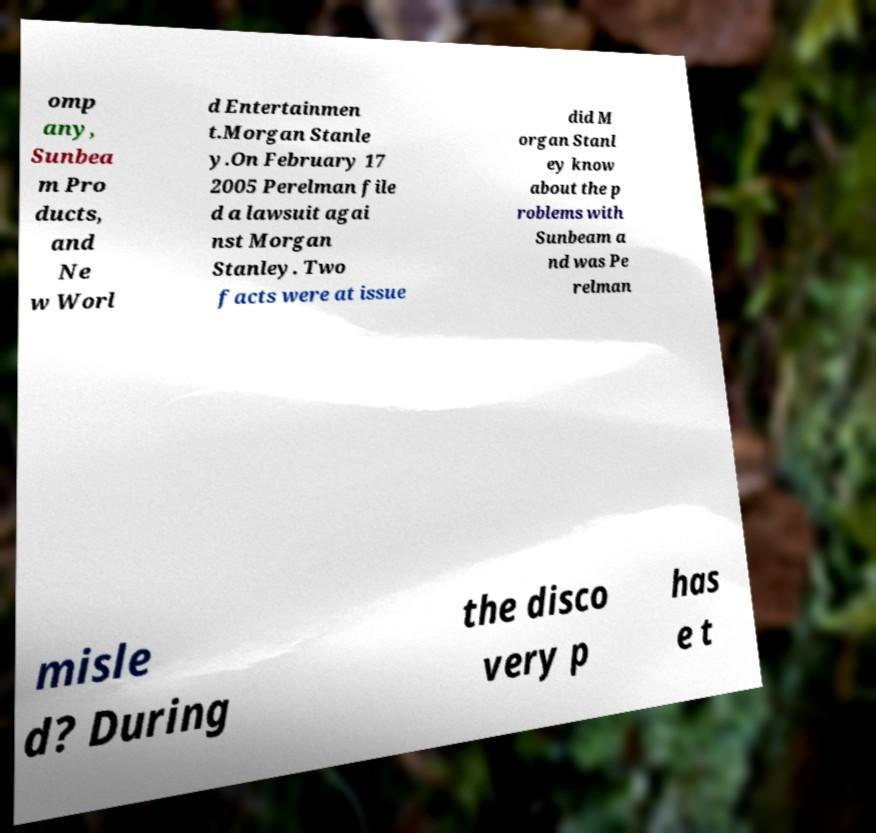I need the written content from this picture converted into text. Can you do that? omp any, Sunbea m Pro ducts, and Ne w Worl d Entertainmen t.Morgan Stanle y.On February 17 2005 Perelman file d a lawsuit agai nst Morgan Stanley. Two facts were at issue did M organ Stanl ey know about the p roblems with Sunbeam a nd was Pe relman misle d? During the disco very p has e t 